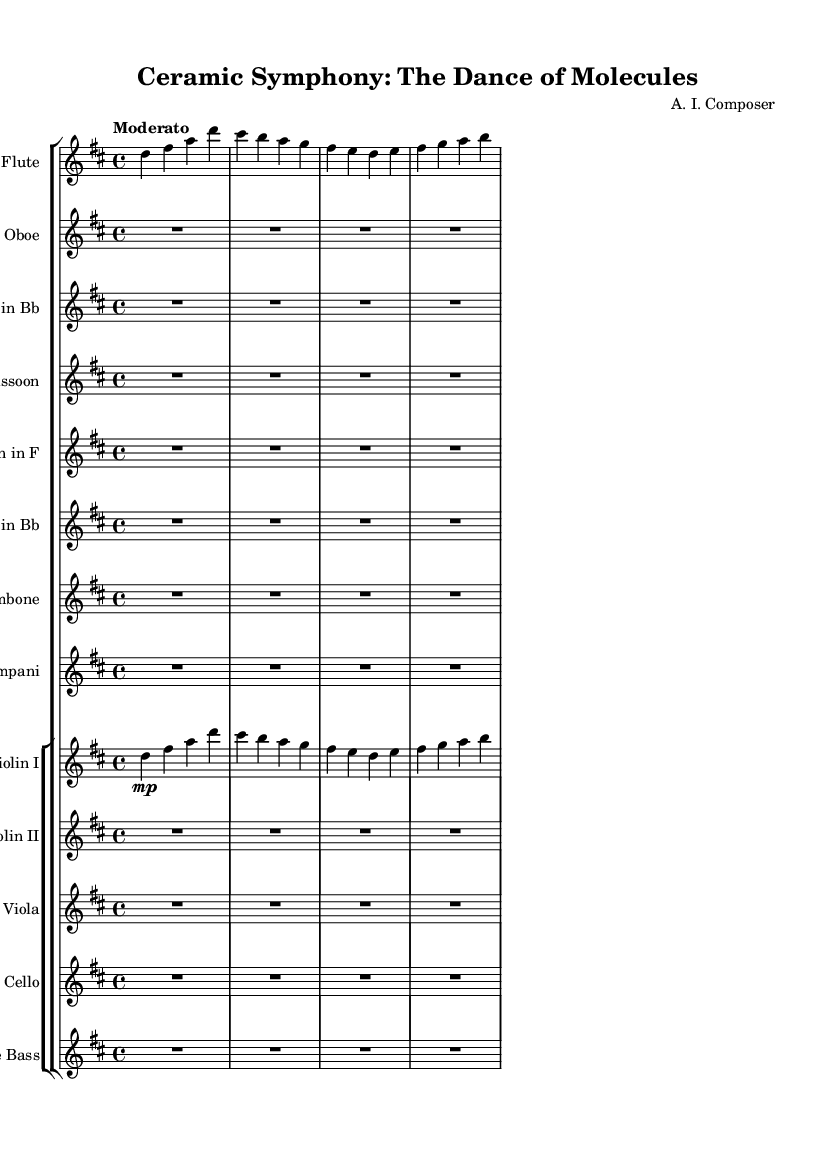What is the key signature of this music? The key signature is indicated by the sharp symbol on the staff. In this score, there are two sharps (F# and C#), which indicates that the piece is in D major.
Answer: D major What is the time signature of this music? The time signature is represented at the beginning of the score, shown as 4/4. This means there are four beats in each measure and the quarter note receives one beat.
Answer: 4/4 What is the tempo marking for this piece? The tempo marking is typically found near the top of the score. In this case, it says "Moderato," which indicates a moderately paced tempo.
Answer: Moderato How many instruments are scored in this symphony? By counting the distinct staves listed in the orchestral score, we can see that there are twelve instruments indicated throughout the piece.
Answer: Twelve Which instrument has the first thematic entry in this piece? The flute part shows the first melodic content in the score while other instruments have rests, indicating that it is the first instrument to play.
Answer: Flute What are the dynamics indicated for the first violin? The dynamics for the first violin are indicated by the markings on the staff; "mp" indicates a mezzo-piano, which means moderately soft.
Answer: mezzo-piano 